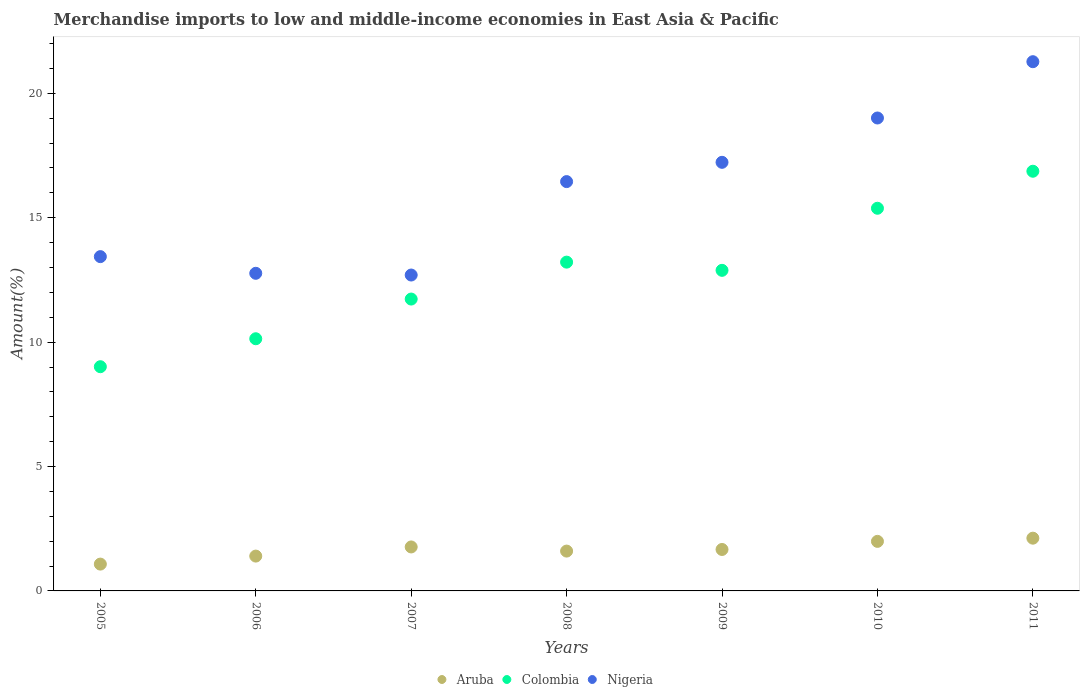How many different coloured dotlines are there?
Offer a very short reply. 3. What is the percentage of amount earned from merchandise imports in Nigeria in 2006?
Keep it short and to the point. 12.77. Across all years, what is the maximum percentage of amount earned from merchandise imports in Aruba?
Give a very brief answer. 2.12. Across all years, what is the minimum percentage of amount earned from merchandise imports in Colombia?
Your response must be concise. 9.01. In which year was the percentage of amount earned from merchandise imports in Colombia maximum?
Your answer should be very brief. 2011. In which year was the percentage of amount earned from merchandise imports in Colombia minimum?
Provide a succinct answer. 2005. What is the total percentage of amount earned from merchandise imports in Colombia in the graph?
Offer a very short reply. 89.23. What is the difference between the percentage of amount earned from merchandise imports in Aruba in 2008 and that in 2009?
Your answer should be very brief. -0.06. What is the difference between the percentage of amount earned from merchandise imports in Nigeria in 2010 and the percentage of amount earned from merchandise imports in Colombia in 2009?
Make the answer very short. 6.12. What is the average percentage of amount earned from merchandise imports in Aruba per year?
Ensure brevity in your answer.  1.66. In the year 2008, what is the difference between the percentage of amount earned from merchandise imports in Colombia and percentage of amount earned from merchandise imports in Nigeria?
Give a very brief answer. -3.24. In how many years, is the percentage of amount earned from merchandise imports in Nigeria greater than 2 %?
Your answer should be compact. 7. What is the ratio of the percentage of amount earned from merchandise imports in Aruba in 2009 to that in 2010?
Offer a terse response. 0.84. Is the percentage of amount earned from merchandise imports in Nigeria in 2007 less than that in 2011?
Ensure brevity in your answer.  Yes. Is the difference between the percentage of amount earned from merchandise imports in Colombia in 2005 and 2011 greater than the difference between the percentage of amount earned from merchandise imports in Nigeria in 2005 and 2011?
Offer a very short reply. No. What is the difference between the highest and the second highest percentage of amount earned from merchandise imports in Nigeria?
Your answer should be compact. 2.26. What is the difference between the highest and the lowest percentage of amount earned from merchandise imports in Colombia?
Your answer should be very brief. 7.86. Does the percentage of amount earned from merchandise imports in Nigeria monotonically increase over the years?
Provide a succinct answer. No. Is the percentage of amount earned from merchandise imports in Colombia strictly greater than the percentage of amount earned from merchandise imports in Nigeria over the years?
Your response must be concise. No. Is the percentage of amount earned from merchandise imports in Nigeria strictly less than the percentage of amount earned from merchandise imports in Colombia over the years?
Offer a very short reply. No. How many dotlines are there?
Provide a short and direct response. 3. How many years are there in the graph?
Offer a terse response. 7. Does the graph contain grids?
Provide a succinct answer. No. Where does the legend appear in the graph?
Offer a very short reply. Bottom center. How many legend labels are there?
Your answer should be very brief. 3. How are the legend labels stacked?
Make the answer very short. Horizontal. What is the title of the graph?
Offer a very short reply. Merchandise imports to low and middle-income economies in East Asia & Pacific. What is the label or title of the Y-axis?
Provide a succinct answer. Amount(%). What is the Amount(%) in Aruba in 2005?
Ensure brevity in your answer.  1.08. What is the Amount(%) of Colombia in 2005?
Keep it short and to the point. 9.01. What is the Amount(%) of Nigeria in 2005?
Offer a terse response. 13.44. What is the Amount(%) in Aruba in 2006?
Give a very brief answer. 1.4. What is the Amount(%) in Colombia in 2006?
Keep it short and to the point. 10.14. What is the Amount(%) in Nigeria in 2006?
Your answer should be compact. 12.77. What is the Amount(%) of Aruba in 2007?
Ensure brevity in your answer.  1.77. What is the Amount(%) of Colombia in 2007?
Ensure brevity in your answer.  11.73. What is the Amount(%) in Nigeria in 2007?
Give a very brief answer. 12.7. What is the Amount(%) in Aruba in 2008?
Make the answer very short. 1.6. What is the Amount(%) of Colombia in 2008?
Your answer should be compact. 13.22. What is the Amount(%) in Nigeria in 2008?
Ensure brevity in your answer.  16.45. What is the Amount(%) of Aruba in 2009?
Provide a short and direct response. 1.67. What is the Amount(%) in Colombia in 2009?
Provide a succinct answer. 12.89. What is the Amount(%) of Nigeria in 2009?
Your answer should be compact. 17.23. What is the Amount(%) of Aruba in 2010?
Your answer should be very brief. 1.99. What is the Amount(%) of Colombia in 2010?
Your response must be concise. 15.38. What is the Amount(%) of Nigeria in 2010?
Your response must be concise. 19.01. What is the Amount(%) in Aruba in 2011?
Your response must be concise. 2.12. What is the Amount(%) of Colombia in 2011?
Give a very brief answer. 16.87. What is the Amount(%) of Nigeria in 2011?
Provide a short and direct response. 21.27. Across all years, what is the maximum Amount(%) in Aruba?
Make the answer very short. 2.12. Across all years, what is the maximum Amount(%) in Colombia?
Ensure brevity in your answer.  16.87. Across all years, what is the maximum Amount(%) of Nigeria?
Make the answer very short. 21.27. Across all years, what is the minimum Amount(%) in Aruba?
Make the answer very short. 1.08. Across all years, what is the minimum Amount(%) of Colombia?
Offer a terse response. 9.01. Across all years, what is the minimum Amount(%) in Nigeria?
Provide a short and direct response. 12.7. What is the total Amount(%) in Aruba in the graph?
Make the answer very short. 11.62. What is the total Amount(%) in Colombia in the graph?
Your response must be concise. 89.23. What is the total Amount(%) in Nigeria in the graph?
Keep it short and to the point. 112.86. What is the difference between the Amount(%) of Aruba in 2005 and that in 2006?
Make the answer very short. -0.32. What is the difference between the Amount(%) of Colombia in 2005 and that in 2006?
Your answer should be compact. -1.12. What is the difference between the Amount(%) in Nigeria in 2005 and that in 2006?
Your response must be concise. 0.67. What is the difference between the Amount(%) in Aruba in 2005 and that in 2007?
Your answer should be very brief. -0.69. What is the difference between the Amount(%) in Colombia in 2005 and that in 2007?
Your answer should be compact. -2.72. What is the difference between the Amount(%) of Nigeria in 2005 and that in 2007?
Make the answer very short. 0.74. What is the difference between the Amount(%) in Aruba in 2005 and that in 2008?
Your answer should be compact. -0.52. What is the difference between the Amount(%) of Colombia in 2005 and that in 2008?
Your answer should be compact. -4.2. What is the difference between the Amount(%) in Nigeria in 2005 and that in 2008?
Your answer should be very brief. -3.02. What is the difference between the Amount(%) of Aruba in 2005 and that in 2009?
Make the answer very short. -0.59. What is the difference between the Amount(%) in Colombia in 2005 and that in 2009?
Your answer should be very brief. -3.87. What is the difference between the Amount(%) of Nigeria in 2005 and that in 2009?
Ensure brevity in your answer.  -3.79. What is the difference between the Amount(%) in Aruba in 2005 and that in 2010?
Provide a succinct answer. -0.91. What is the difference between the Amount(%) of Colombia in 2005 and that in 2010?
Keep it short and to the point. -6.37. What is the difference between the Amount(%) in Nigeria in 2005 and that in 2010?
Your response must be concise. -5.57. What is the difference between the Amount(%) of Aruba in 2005 and that in 2011?
Provide a short and direct response. -1.04. What is the difference between the Amount(%) in Colombia in 2005 and that in 2011?
Your answer should be very brief. -7.86. What is the difference between the Amount(%) of Nigeria in 2005 and that in 2011?
Provide a succinct answer. -7.84. What is the difference between the Amount(%) of Aruba in 2006 and that in 2007?
Offer a terse response. -0.37. What is the difference between the Amount(%) of Colombia in 2006 and that in 2007?
Ensure brevity in your answer.  -1.6. What is the difference between the Amount(%) in Nigeria in 2006 and that in 2007?
Offer a very short reply. 0.07. What is the difference between the Amount(%) of Aruba in 2006 and that in 2008?
Offer a very short reply. -0.2. What is the difference between the Amount(%) in Colombia in 2006 and that in 2008?
Make the answer very short. -3.08. What is the difference between the Amount(%) in Nigeria in 2006 and that in 2008?
Keep it short and to the point. -3.69. What is the difference between the Amount(%) in Aruba in 2006 and that in 2009?
Keep it short and to the point. -0.27. What is the difference between the Amount(%) of Colombia in 2006 and that in 2009?
Offer a very short reply. -2.75. What is the difference between the Amount(%) in Nigeria in 2006 and that in 2009?
Provide a succinct answer. -4.46. What is the difference between the Amount(%) of Aruba in 2006 and that in 2010?
Your response must be concise. -0.59. What is the difference between the Amount(%) in Colombia in 2006 and that in 2010?
Keep it short and to the point. -5.24. What is the difference between the Amount(%) in Nigeria in 2006 and that in 2010?
Keep it short and to the point. -6.24. What is the difference between the Amount(%) in Aruba in 2006 and that in 2011?
Provide a short and direct response. -0.72. What is the difference between the Amount(%) of Colombia in 2006 and that in 2011?
Provide a short and direct response. -6.73. What is the difference between the Amount(%) of Nigeria in 2006 and that in 2011?
Provide a short and direct response. -8.51. What is the difference between the Amount(%) in Aruba in 2007 and that in 2008?
Provide a succinct answer. 0.17. What is the difference between the Amount(%) of Colombia in 2007 and that in 2008?
Your answer should be compact. -1.48. What is the difference between the Amount(%) of Nigeria in 2007 and that in 2008?
Provide a succinct answer. -3.76. What is the difference between the Amount(%) in Aruba in 2007 and that in 2009?
Provide a short and direct response. 0.1. What is the difference between the Amount(%) of Colombia in 2007 and that in 2009?
Make the answer very short. -1.15. What is the difference between the Amount(%) in Nigeria in 2007 and that in 2009?
Offer a very short reply. -4.53. What is the difference between the Amount(%) of Aruba in 2007 and that in 2010?
Ensure brevity in your answer.  -0.22. What is the difference between the Amount(%) of Colombia in 2007 and that in 2010?
Keep it short and to the point. -3.65. What is the difference between the Amount(%) in Nigeria in 2007 and that in 2010?
Your response must be concise. -6.31. What is the difference between the Amount(%) in Aruba in 2007 and that in 2011?
Keep it short and to the point. -0.35. What is the difference between the Amount(%) in Colombia in 2007 and that in 2011?
Offer a very short reply. -5.14. What is the difference between the Amount(%) of Nigeria in 2007 and that in 2011?
Provide a short and direct response. -8.57. What is the difference between the Amount(%) in Aruba in 2008 and that in 2009?
Make the answer very short. -0.07. What is the difference between the Amount(%) of Colombia in 2008 and that in 2009?
Provide a succinct answer. 0.33. What is the difference between the Amount(%) of Nigeria in 2008 and that in 2009?
Keep it short and to the point. -0.78. What is the difference between the Amount(%) of Aruba in 2008 and that in 2010?
Ensure brevity in your answer.  -0.39. What is the difference between the Amount(%) of Colombia in 2008 and that in 2010?
Your response must be concise. -2.17. What is the difference between the Amount(%) of Nigeria in 2008 and that in 2010?
Your response must be concise. -2.56. What is the difference between the Amount(%) of Aruba in 2008 and that in 2011?
Provide a succinct answer. -0.52. What is the difference between the Amount(%) of Colombia in 2008 and that in 2011?
Give a very brief answer. -3.65. What is the difference between the Amount(%) of Nigeria in 2008 and that in 2011?
Keep it short and to the point. -4.82. What is the difference between the Amount(%) of Aruba in 2009 and that in 2010?
Provide a short and direct response. -0.33. What is the difference between the Amount(%) of Colombia in 2009 and that in 2010?
Offer a very short reply. -2.5. What is the difference between the Amount(%) of Nigeria in 2009 and that in 2010?
Ensure brevity in your answer.  -1.78. What is the difference between the Amount(%) in Aruba in 2009 and that in 2011?
Give a very brief answer. -0.45. What is the difference between the Amount(%) of Colombia in 2009 and that in 2011?
Make the answer very short. -3.98. What is the difference between the Amount(%) of Nigeria in 2009 and that in 2011?
Your answer should be compact. -4.04. What is the difference between the Amount(%) in Aruba in 2010 and that in 2011?
Make the answer very short. -0.13. What is the difference between the Amount(%) in Colombia in 2010 and that in 2011?
Provide a short and direct response. -1.49. What is the difference between the Amount(%) of Nigeria in 2010 and that in 2011?
Give a very brief answer. -2.26. What is the difference between the Amount(%) in Aruba in 2005 and the Amount(%) in Colombia in 2006?
Give a very brief answer. -9.06. What is the difference between the Amount(%) of Aruba in 2005 and the Amount(%) of Nigeria in 2006?
Provide a short and direct response. -11.69. What is the difference between the Amount(%) of Colombia in 2005 and the Amount(%) of Nigeria in 2006?
Your answer should be compact. -3.75. What is the difference between the Amount(%) of Aruba in 2005 and the Amount(%) of Colombia in 2007?
Provide a short and direct response. -10.65. What is the difference between the Amount(%) of Aruba in 2005 and the Amount(%) of Nigeria in 2007?
Offer a terse response. -11.62. What is the difference between the Amount(%) in Colombia in 2005 and the Amount(%) in Nigeria in 2007?
Your answer should be very brief. -3.68. What is the difference between the Amount(%) in Aruba in 2005 and the Amount(%) in Colombia in 2008?
Ensure brevity in your answer.  -12.14. What is the difference between the Amount(%) in Aruba in 2005 and the Amount(%) in Nigeria in 2008?
Your answer should be compact. -15.37. What is the difference between the Amount(%) of Colombia in 2005 and the Amount(%) of Nigeria in 2008?
Keep it short and to the point. -7.44. What is the difference between the Amount(%) of Aruba in 2005 and the Amount(%) of Colombia in 2009?
Your answer should be very brief. -11.81. What is the difference between the Amount(%) in Aruba in 2005 and the Amount(%) in Nigeria in 2009?
Your answer should be compact. -16.15. What is the difference between the Amount(%) in Colombia in 2005 and the Amount(%) in Nigeria in 2009?
Offer a very short reply. -8.21. What is the difference between the Amount(%) of Aruba in 2005 and the Amount(%) of Colombia in 2010?
Provide a succinct answer. -14.3. What is the difference between the Amount(%) in Aruba in 2005 and the Amount(%) in Nigeria in 2010?
Offer a terse response. -17.93. What is the difference between the Amount(%) in Colombia in 2005 and the Amount(%) in Nigeria in 2010?
Offer a very short reply. -10. What is the difference between the Amount(%) in Aruba in 2005 and the Amount(%) in Colombia in 2011?
Give a very brief answer. -15.79. What is the difference between the Amount(%) of Aruba in 2005 and the Amount(%) of Nigeria in 2011?
Provide a succinct answer. -20.19. What is the difference between the Amount(%) of Colombia in 2005 and the Amount(%) of Nigeria in 2011?
Offer a very short reply. -12.26. What is the difference between the Amount(%) of Aruba in 2006 and the Amount(%) of Colombia in 2007?
Provide a short and direct response. -10.33. What is the difference between the Amount(%) of Aruba in 2006 and the Amount(%) of Nigeria in 2007?
Your response must be concise. -11.3. What is the difference between the Amount(%) in Colombia in 2006 and the Amount(%) in Nigeria in 2007?
Keep it short and to the point. -2.56. What is the difference between the Amount(%) in Aruba in 2006 and the Amount(%) in Colombia in 2008?
Ensure brevity in your answer.  -11.82. What is the difference between the Amount(%) in Aruba in 2006 and the Amount(%) in Nigeria in 2008?
Your response must be concise. -15.05. What is the difference between the Amount(%) in Colombia in 2006 and the Amount(%) in Nigeria in 2008?
Make the answer very short. -6.32. What is the difference between the Amount(%) in Aruba in 2006 and the Amount(%) in Colombia in 2009?
Offer a very short reply. -11.49. What is the difference between the Amount(%) of Aruba in 2006 and the Amount(%) of Nigeria in 2009?
Ensure brevity in your answer.  -15.83. What is the difference between the Amount(%) in Colombia in 2006 and the Amount(%) in Nigeria in 2009?
Offer a very short reply. -7.09. What is the difference between the Amount(%) of Aruba in 2006 and the Amount(%) of Colombia in 2010?
Provide a succinct answer. -13.98. What is the difference between the Amount(%) of Aruba in 2006 and the Amount(%) of Nigeria in 2010?
Offer a terse response. -17.61. What is the difference between the Amount(%) in Colombia in 2006 and the Amount(%) in Nigeria in 2010?
Provide a succinct answer. -8.87. What is the difference between the Amount(%) in Aruba in 2006 and the Amount(%) in Colombia in 2011?
Offer a very short reply. -15.47. What is the difference between the Amount(%) in Aruba in 2006 and the Amount(%) in Nigeria in 2011?
Offer a terse response. -19.87. What is the difference between the Amount(%) in Colombia in 2006 and the Amount(%) in Nigeria in 2011?
Keep it short and to the point. -11.14. What is the difference between the Amount(%) of Aruba in 2007 and the Amount(%) of Colombia in 2008?
Offer a very short reply. -11.45. What is the difference between the Amount(%) of Aruba in 2007 and the Amount(%) of Nigeria in 2008?
Your response must be concise. -14.68. What is the difference between the Amount(%) in Colombia in 2007 and the Amount(%) in Nigeria in 2008?
Ensure brevity in your answer.  -4.72. What is the difference between the Amount(%) in Aruba in 2007 and the Amount(%) in Colombia in 2009?
Offer a terse response. -11.12. What is the difference between the Amount(%) in Aruba in 2007 and the Amount(%) in Nigeria in 2009?
Offer a terse response. -15.46. What is the difference between the Amount(%) of Colombia in 2007 and the Amount(%) of Nigeria in 2009?
Your answer should be compact. -5.5. What is the difference between the Amount(%) in Aruba in 2007 and the Amount(%) in Colombia in 2010?
Provide a succinct answer. -13.61. What is the difference between the Amount(%) of Aruba in 2007 and the Amount(%) of Nigeria in 2010?
Make the answer very short. -17.24. What is the difference between the Amount(%) in Colombia in 2007 and the Amount(%) in Nigeria in 2010?
Give a very brief answer. -7.28. What is the difference between the Amount(%) in Aruba in 2007 and the Amount(%) in Colombia in 2011?
Your answer should be compact. -15.1. What is the difference between the Amount(%) of Aruba in 2007 and the Amount(%) of Nigeria in 2011?
Provide a short and direct response. -19.5. What is the difference between the Amount(%) in Colombia in 2007 and the Amount(%) in Nigeria in 2011?
Make the answer very short. -9.54. What is the difference between the Amount(%) in Aruba in 2008 and the Amount(%) in Colombia in 2009?
Keep it short and to the point. -11.28. What is the difference between the Amount(%) of Aruba in 2008 and the Amount(%) of Nigeria in 2009?
Your answer should be compact. -15.63. What is the difference between the Amount(%) in Colombia in 2008 and the Amount(%) in Nigeria in 2009?
Ensure brevity in your answer.  -4.01. What is the difference between the Amount(%) of Aruba in 2008 and the Amount(%) of Colombia in 2010?
Provide a succinct answer. -13.78. What is the difference between the Amount(%) of Aruba in 2008 and the Amount(%) of Nigeria in 2010?
Your answer should be compact. -17.41. What is the difference between the Amount(%) of Colombia in 2008 and the Amount(%) of Nigeria in 2010?
Provide a short and direct response. -5.79. What is the difference between the Amount(%) in Aruba in 2008 and the Amount(%) in Colombia in 2011?
Your answer should be very brief. -15.27. What is the difference between the Amount(%) of Aruba in 2008 and the Amount(%) of Nigeria in 2011?
Your response must be concise. -19.67. What is the difference between the Amount(%) of Colombia in 2008 and the Amount(%) of Nigeria in 2011?
Your answer should be very brief. -8.06. What is the difference between the Amount(%) in Aruba in 2009 and the Amount(%) in Colombia in 2010?
Offer a terse response. -13.71. What is the difference between the Amount(%) of Aruba in 2009 and the Amount(%) of Nigeria in 2010?
Keep it short and to the point. -17.34. What is the difference between the Amount(%) in Colombia in 2009 and the Amount(%) in Nigeria in 2010?
Make the answer very short. -6.12. What is the difference between the Amount(%) of Aruba in 2009 and the Amount(%) of Colombia in 2011?
Your answer should be very brief. -15.2. What is the difference between the Amount(%) of Aruba in 2009 and the Amount(%) of Nigeria in 2011?
Provide a succinct answer. -19.61. What is the difference between the Amount(%) in Colombia in 2009 and the Amount(%) in Nigeria in 2011?
Offer a terse response. -8.39. What is the difference between the Amount(%) of Aruba in 2010 and the Amount(%) of Colombia in 2011?
Make the answer very short. -14.88. What is the difference between the Amount(%) of Aruba in 2010 and the Amount(%) of Nigeria in 2011?
Offer a terse response. -19.28. What is the difference between the Amount(%) in Colombia in 2010 and the Amount(%) in Nigeria in 2011?
Give a very brief answer. -5.89. What is the average Amount(%) in Aruba per year?
Your response must be concise. 1.66. What is the average Amount(%) in Colombia per year?
Keep it short and to the point. 12.75. What is the average Amount(%) of Nigeria per year?
Your response must be concise. 16.12. In the year 2005, what is the difference between the Amount(%) in Aruba and Amount(%) in Colombia?
Make the answer very short. -7.93. In the year 2005, what is the difference between the Amount(%) in Aruba and Amount(%) in Nigeria?
Your response must be concise. -12.36. In the year 2005, what is the difference between the Amount(%) of Colombia and Amount(%) of Nigeria?
Your response must be concise. -4.42. In the year 2006, what is the difference between the Amount(%) in Aruba and Amount(%) in Colombia?
Your answer should be compact. -8.74. In the year 2006, what is the difference between the Amount(%) in Aruba and Amount(%) in Nigeria?
Ensure brevity in your answer.  -11.37. In the year 2006, what is the difference between the Amount(%) of Colombia and Amount(%) of Nigeria?
Your answer should be compact. -2.63. In the year 2007, what is the difference between the Amount(%) of Aruba and Amount(%) of Colombia?
Provide a succinct answer. -9.96. In the year 2007, what is the difference between the Amount(%) in Aruba and Amount(%) in Nigeria?
Offer a very short reply. -10.93. In the year 2007, what is the difference between the Amount(%) of Colombia and Amount(%) of Nigeria?
Give a very brief answer. -0.97. In the year 2008, what is the difference between the Amount(%) of Aruba and Amount(%) of Colombia?
Your answer should be compact. -11.61. In the year 2008, what is the difference between the Amount(%) in Aruba and Amount(%) in Nigeria?
Provide a succinct answer. -14.85. In the year 2008, what is the difference between the Amount(%) in Colombia and Amount(%) in Nigeria?
Provide a succinct answer. -3.24. In the year 2009, what is the difference between the Amount(%) in Aruba and Amount(%) in Colombia?
Your answer should be very brief. -11.22. In the year 2009, what is the difference between the Amount(%) of Aruba and Amount(%) of Nigeria?
Your response must be concise. -15.56. In the year 2009, what is the difference between the Amount(%) of Colombia and Amount(%) of Nigeria?
Ensure brevity in your answer.  -4.34. In the year 2010, what is the difference between the Amount(%) in Aruba and Amount(%) in Colombia?
Offer a very short reply. -13.39. In the year 2010, what is the difference between the Amount(%) of Aruba and Amount(%) of Nigeria?
Make the answer very short. -17.02. In the year 2010, what is the difference between the Amount(%) of Colombia and Amount(%) of Nigeria?
Give a very brief answer. -3.63. In the year 2011, what is the difference between the Amount(%) in Aruba and Amount(%) in Colombia?
Keep it short and to the point. -14.75. In the year 2011, what is the difference between the Amount(%) of Aruba and Amount(%) of Nigeria?
Your answer should be very brief. -19.15. In the year 2011, what is the difference between the Amount(%) in Colombia and Amount(%) in Nigeria?
Give a very brief answer. -4.4. What is the ratio of the Amount(%) of Aruba in 2005 to that in 2006?
Ensure brevity in your answer.  0.77. What is the ratio of the Amount(%) of Colombia in 2005 to that in 2006?
Ensure brevity in your answer.  0.89. What is the ratio of the Amount(%) in Nigeria in 2005 to that in 2006?
Your answer should be compact. 1.05. What is the ratio of the Amount(%) of Aruba in 2005 to that in 2007?
Offer a very short reply. 0.61. What is the ratio of the Amount(%) in Colombia in 2005 to that in 2007?
Your response must be concise. 0.77. What is the ratio of the Amount(%) of Nigeria in 2005 to that in 2007?
Make the answer very short. 1.06. What is the ratio of the Amount(%) in Aruba in 2005 to that in 2008?
Offer a very short reply. 0.67. What is the ratio of the Amount(%) in Colombia in 2005 to that in 2008?
Make the answer very short. 0.68. What is the ratio of the Amount(%) of Nigeria in 2005 to that in 2008?
Make the answer very short. 0.82. What is the ratio of the Amount(%) in Aruba in 2005 to that in 2009?
Give a very brief answer. 0.65. What is the ratio of the Amount(%) in Colombia in 2005 to that in 2009?
Make the answer very short. 0.7. What is the ratio of the Amount(%) of Nigeria in 2005 to that in 2009?
Provide a succinct answer. 0.78. What is the ratio of the Amount(%) of Aruba in 2005 to that in 2010?
Provide a short and direct response. 0.54. What is the ratio of the Amount(%) in Colombia in 2005 to that in 2010?
Ensure brevity in your answer.  0.59. What is the ratio of the Amount(%) in Nigeria in 2005 to that in 2010?
Keep it short and to the point. 0.71. What is the ratio of the Amount(%) of Aruba in 2005 to that in 2011?
Your answer should be very brief. 0.51. What is the ratio of the Amount(%) in Colombia in 2005 to that in 2011?
Keep it short and to the point. 0.53. What is the ratio of the Amount(%) in Nigeria in 2005 to that in 2011?
Make the answer very short. 0.63. What is the ratio of the Amount(%) in Aruba in 2006 to that in 2007?
Your response must be concise. 0.79. What is the ratio of the Amount(%) in Colombia in 2006 to that in 2007?
Offer a very short reply. 0.86. What is the ratio of the Amount(%) in Nigeria in 2006 to that in 2007?
Offer a terse response. 1.01. What is the ratio of the Amount(%) of Aruba in 2006 to that in 2008?
Your response must be concise. 0.87. What is the ratio of the Amount(%) of Colombia in 2006 to that in 2008?
Keep it short and to the point. 0.77. What is the ratio of the Amount(%) of Nigeria in 2006 to that in 2008?
Your answer should be compact. 0.78. What is the ratio of the Amount(%) in Aruba in 2006 to that in 2009?
Ensure brevity in your answer.  0.84. What is the ratio of the Amount(%) in Colombia in 2006 to that in 2009?
Provide a short and direct response. 0.79. What is the ratio of the Amount(%) of Nigeria in 2006 to that in 2009?
Provide a succinct answer. 0.74. What is the ratio of the Amount(%) of Aruba in 2006 to that in 2010?
Give a very brief answer. 0.7. What is the ratio of the Amount(%) of Colombia in 2006 to that in 2010?
Keep it short and to the point. 0.66. What is the ratio of the Amount(%) in Nigeria in 2006 to that in 2010?
Your response must be concise. 0.67. What is the ratio of the Amount(%) in Aruba in 2006 to that in 2011?
Keep it short and to the point. 0.66. What is the ratio of the Amount(%) of Colombia in 2006 to that in 2011?
Your response must be concise. 0.6. What is the ratio of the Amount(%) of Nigeria in 2006 to that in 2011?
Provide a succinct answer. 0.6. What is the ratio of the Amount(%) of Aruba in 2007 to that in 2008?
Your answer should be compact. 1.1. What is the ratio of the Amount(%) of Colombia in 2007 to that in 2008?
Make the answer very short. 0.89. What is the ratio of the Amount(%) of Nigeria in 2007 to that in 2008?
Your answer should be compact. 0.77. What is the ratio of the Amount(%) in Aruba in 2007 to that in 2009?
Make the answer very short. 1.06. What is the ratio of the Amount(%) in Colombia in 2007 to that in 2009?
Your answer should be compact. 0.91. What is the ratio of the Amount(%) of Nigeria in 2007 to that in 2009?
Keep it short and to the point. 0.74. What is the ratio of the Amount(%) in Aruba in 2007 to that in 2010?
Make the answer very short. 0.89. What is the ratio of the Amount(%) of Colombia in 2007 to that in 2010?
Offer a very short reply. 0.76. What is the ratio of the Amount(%) of Nigeria in 2007 to that in 2010?
Give a very brief answer. 0.67. What is the ratio of the Amount(%) in Aruba in 2007 to that in 2011?
Offer a terse response. 0.83. What is the ratio of the Amount(%) of Colombia in 2007 to that in 2011?
Offer a very short reply. 0.7. What is the ratio of the Amount(%) of Nigeria in 2007 to that in 2011?
Offer a terse response. 0.6. What is the ratio of the Amount(%) of Aruba in 2008 to that in 2009?
Your answer should be compact. 0.96. What is the ratio of the Amount(%) in Colombia in 2008 to that in 2009?
Your response must be concise. 1.03. What is the ratio of the Amount(%) of Nigeria in 2008 to that in 2009?
Your answer should be compact. 0.95. What is the ratio of the Amount(%) in Aruba in 2008 to that in 2010?
Your answer should be compact. 0.8. What is the ratio of the Amount(%) in Colombia in 2008 to that in 2010?
Offer a very short reply. 0.86. What is the ratio of the Amount(%) in Nigeria in 2008 to that in 2010?
Offer a terse response. 0.87. What is the ratio of the Amount(%) of Aruba in 2008 to that in 2011?
Offer a very short reply. 0.76. What is the ratio of the Amount(%) in Colombia in 2008 to that in 2011?
Your response must be concise. 0.78. What is the ratio of the Amount(%) in Nigeria in 2008 to that in 2011?
Offer a very short reply. 0.77. What is the ratio of the Amount(%) in Aruba in 2009 to that in 2010?
Offer a terse response. 0.84. What is the ratio of the Amount(%) in Colombia in 2009 to that in 2010?
Provide a succinct answer. 0.84. What is the ratio of the Amount(%) of Nigeria in 2009 to that in 2010?
Provide a succinct answer. 0.91. What is the ratio of the Amount(%) in Aruba in 2009 to that in 2011?
Give a very brief answer. 0.79. What is the ratio of the Amount(%) of Colombia in 2009 to that in 2011?
Your answer should be compact. 0.76. What is the ratio of the Amount(%) in Nigeria in 2009 to that in 2011?
Provide a short and direct response. 0.81. What is the ratio of the Amount(%) in Aruba in 2010 to that in 2011?
Your answer should be very brief. 0.94. What is the ratio of the Amount(%) in Colombia in 2010 to that in 2011?
Your response must be concise. 0.91. What is the ratio of the Amount(%) of Nigeria in 2010 to that in 2011?
Offer a very short reply. 0.89. What is the difference between the highest and the second highest Amount(%) of Aruba?
Provide a short and direct response. 0.13. What is the difference between the highest and the second highest Amount(%) in Colombia?
Your answer should be compact. 1.49. What is the difference between the highest and the second highest Amount(%) of Nigeria?
Keep it short and to the point. 2.26. What is the difference between the highest and the lowest Amount(%) of Aruba?
Provide a succinct answer. 1.04. What is the difference between the highest and the lowest Amount(%) of Colombia?
Give a very brief answer. 7.86. What is the difference between the highest and the lowest Amount(%) of Nigeria?
Your answer should be compact. 8.57. 